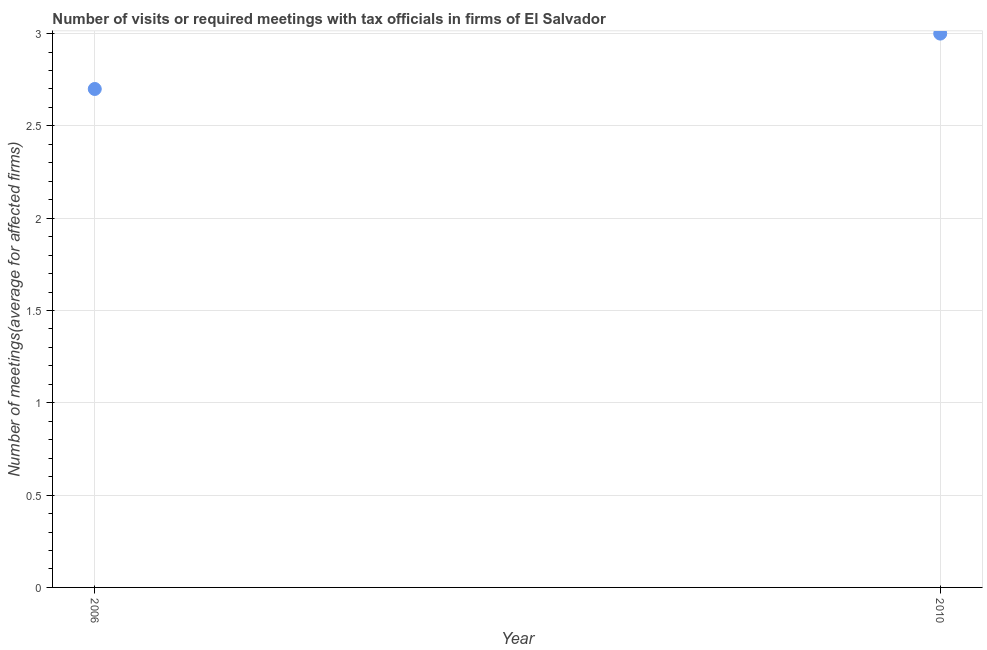Across all years, what is the minimum number of required meetings with tax officials?
Offer a very short reply. 2.7. In which year was the number of required meetings with tax officials minimum?
Your response must be concise. 2006. What is the difference between the number of required meetings with tax officials in 2006 and 2010?
Give a very brief answer. -0.3. What is the average number of required meetings with tax officials per year?
Your answer should be very brief. 2.85. What is the median number of required meetings with tax officials?
Offer a very short reply. 2.85. In how many years, is the number of required meetings with tax officials greater than 2 ?
Make the answer very short. 2. What is the ratio of the number of required meetings with tax officials in 2006 to that in 2010?
Offer a very short reply. 0.9. Is the number of required meetings with tax officials in 2006 less than that in 2010?
Your response must be concise. Yes. Does the graph contain grids?
Offer a terse response. Yes. What is the title of the graph?
Provide a short and direct response. Number of visits or required meetings with tax officials in firms of El Salvador. What is the label or title of the X-axis?
Offer a terse response. Year. What is the label or title of the Y-axis?
Ensure brevity in your answer.  Number of meetings(average for affected firms). What is the ratio of the Number of meetings(average for affected firms) in 2006 to that in 2010?
Your response must be concise. 0.9. 